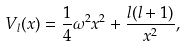<formula> <loc_0><loc_0><loc_500><loc_500>V _ { l } ( x ) = \frac { 1 } { 4 } \omega ^ { 2 } x ^ { 2 } + \frac { l ( l + 1 ) } { x ^ { 2 } } ,</formula> 